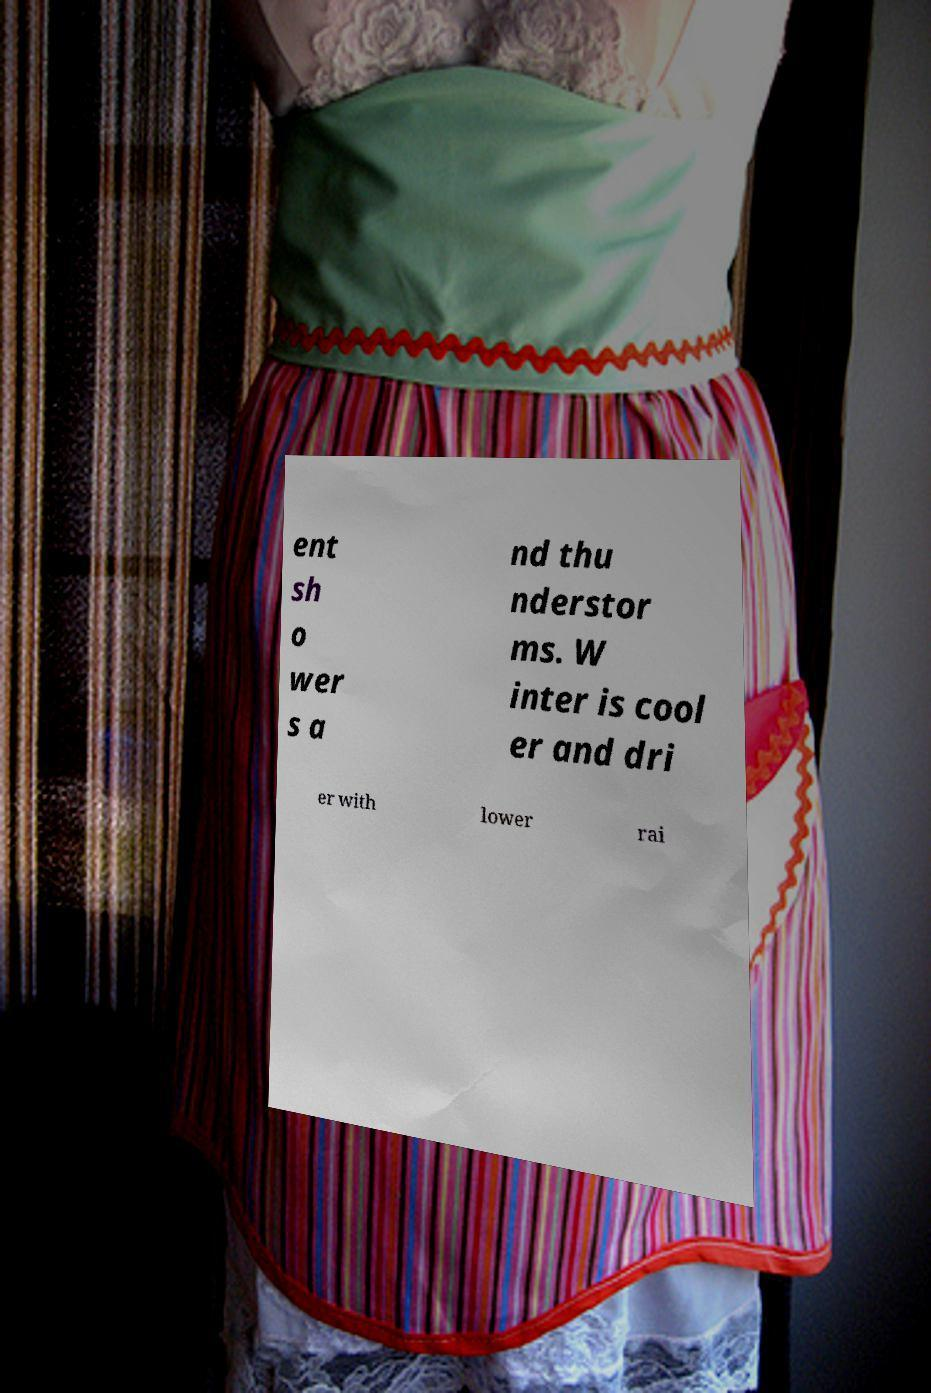Can you accurately transcribe the text from the provided image for me? ent sh o wer s a nd thu nderstor ms. W inter is cool er and dri er with lower rai 